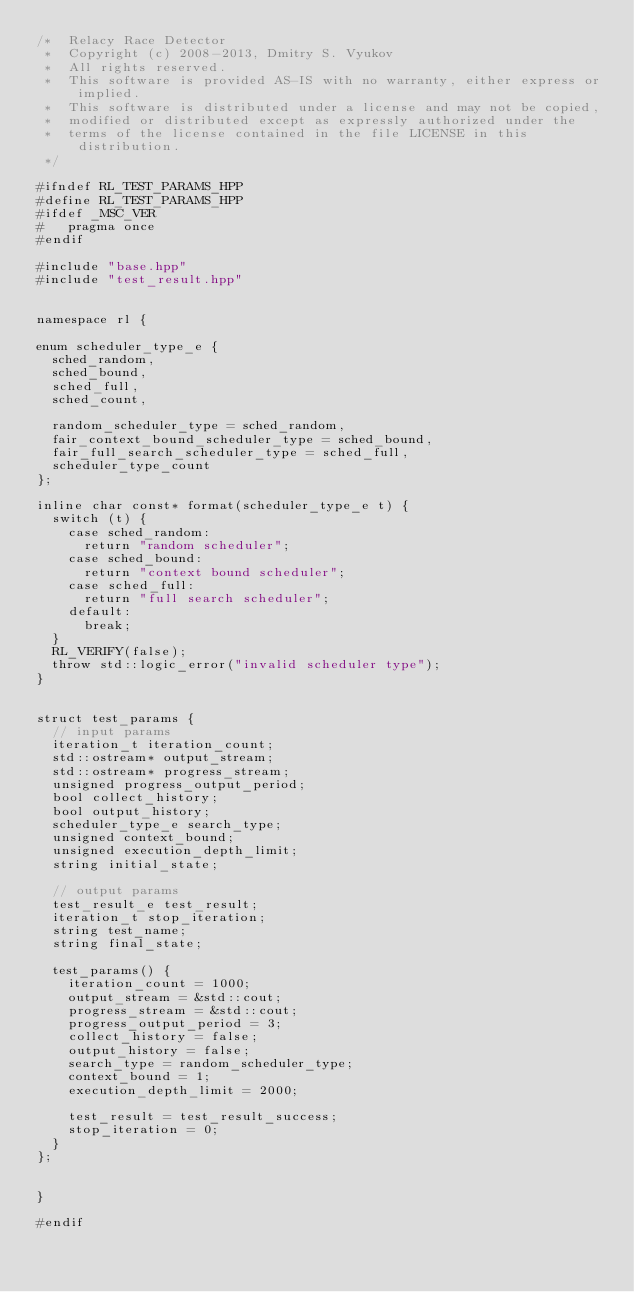Convert code to text. <code><loc_0><loc_0><loc_500><loc_500><_C++_>/*  Relacy Race Detector
 *  Copyright (c) 2008-2013, Dmitry S. Vyukov
 *  All rights reserved.
 *  This software is provided AS-IS with no warranty, either express or implied.
 *  This software is distributed under a license and may not be copied,
 *  modified or distributed except as expressly authorized under the
 *  terms of the license contained in the file LICENSE in this distribution.
 */

#ifndef RL_TEST_PARAMS_HPP
#define RL_TEST_PARAMS_HPP
#ifdef _MSC_VER
#   pragma once
#endif

#include "base.hpp"
#include "test_result.hpp"


namespace rl {

enum scheduler_type_e {
  sched_random,
  sched_bound,
  sched_full,
  sched_count,

  random_scheduler_type = sched_random,
  fair_context_bound_scheduler_type = sched_bound,
  fair_full_search_scheduler_type = sched_full,
  scheduler_type_count
};

inline char const* format(scheduler_type_e t) {
  switch (t) {
    case sched_random:
      return "random scheduler";
    case sched_bound:
      return "context bound scheduler";
    case sched_full:
      return "full search scheduler";
    default:
      break;
  }
  RL_VERIFY(false);
  throw std::logic_error("invalid scheduler type");
}


struct test_params {
  // input params
  iteration_t iteration_count;
  std::ostream* output_stream;
  std::ostream* progress_stream;
  unsigned progress_output_period;
  bool collect_history;
  bool output_history;
  scheduler_type_e search_type;
  unsigned context_bound;
  unsigned execution_depth_limit;
  string initial_state;

  // output params
  test_result_e test_result;
  iteration_t stop_iteration;
  string test_name;
  string final_state;

  test_params() {
    iteration_count = 1000;
    output_stream = &std::cout;
    progress_stream = &std::cout;
    progress_output_period = 3;
    collect_history = false;
    output_history = false;
    search_type = random_scheduler_type;
    context_bound = 1;
    execution_depth_limit = 2000;

    test_result = test_result_success;
    stop_iteration = 0;
  }
};


}

#endif
</code> 